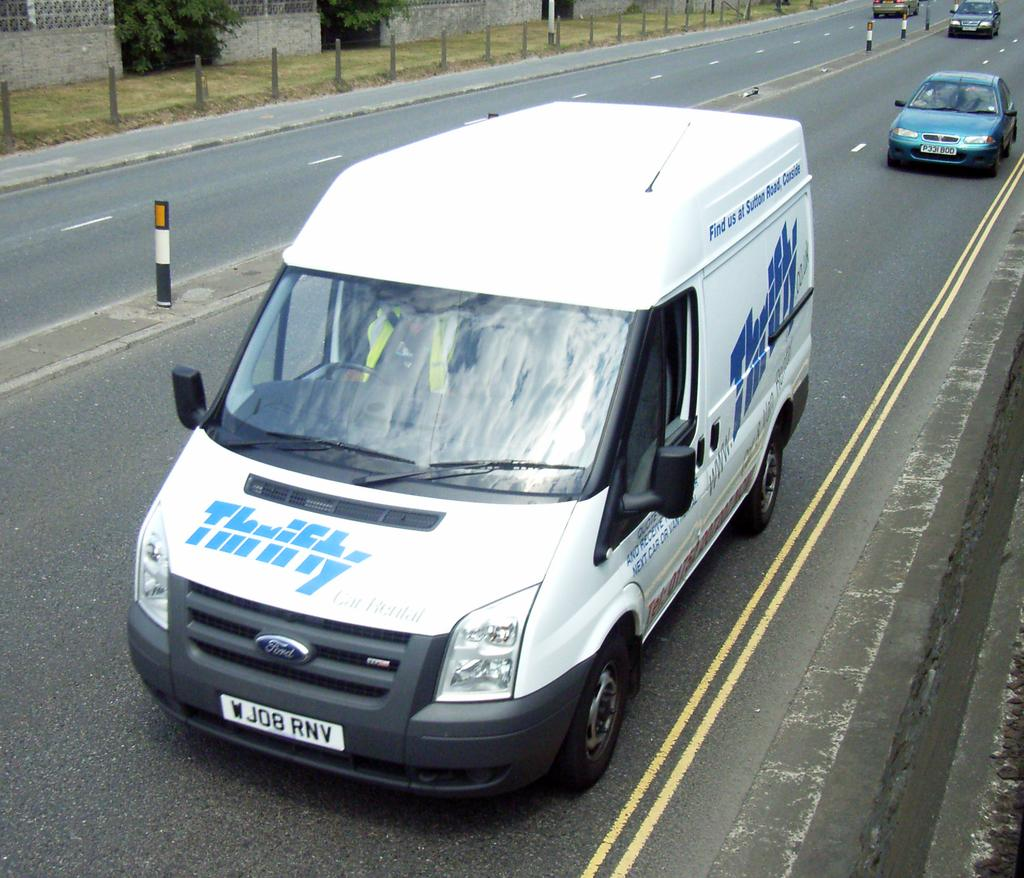What can be seen in the image in terms of transportation? There are different types of vehicles in the image. Where are the vehicles located? The vehicles are riding on the road. What is present on the pavement? There is grass on the pavement. What type of barrier is visible in the image? There is a compound wall in the image. What kind of greenery is associated with the compound wall? There are plants on or near the compound wall. What type of calculator is being used to measure the force of the vehicles in the image? There is no calculator or measurement of force present in the image; it simply shows vehicles riding on the road. 